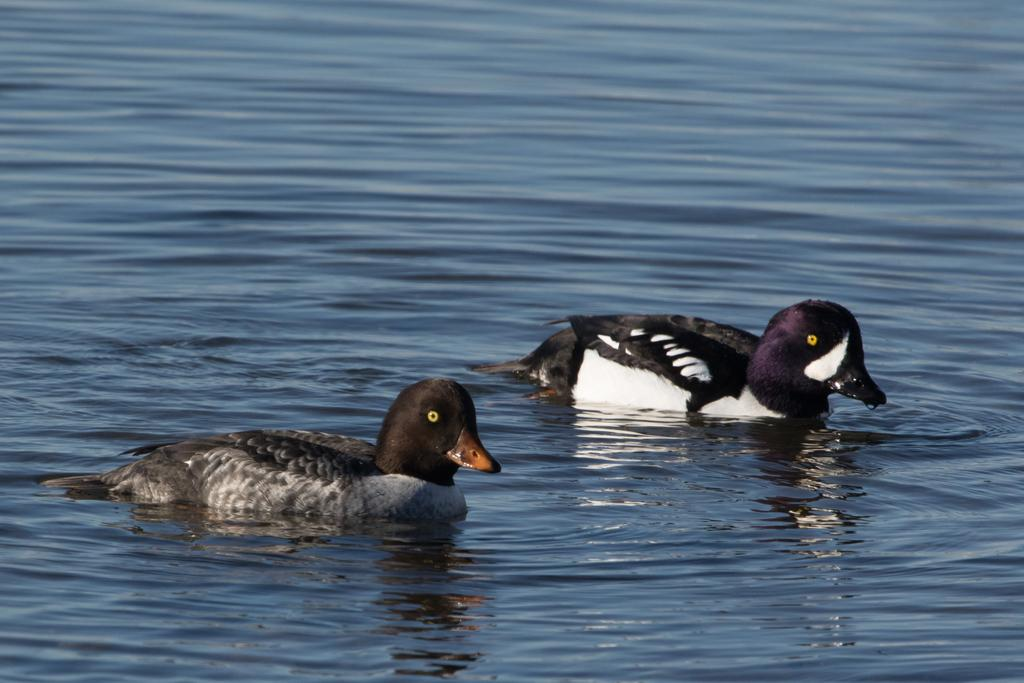What is the primary element visible in the image? There is water in the image. What can be seen on the surface of the water? There are two birds on the surface of the water. Can you describe the appearance of the birds? The birds are white, black, brown, and orange in color. What type of coat is the bird wearing in the image? The birds in the image are not wearing coats; they are birds with feathers. 